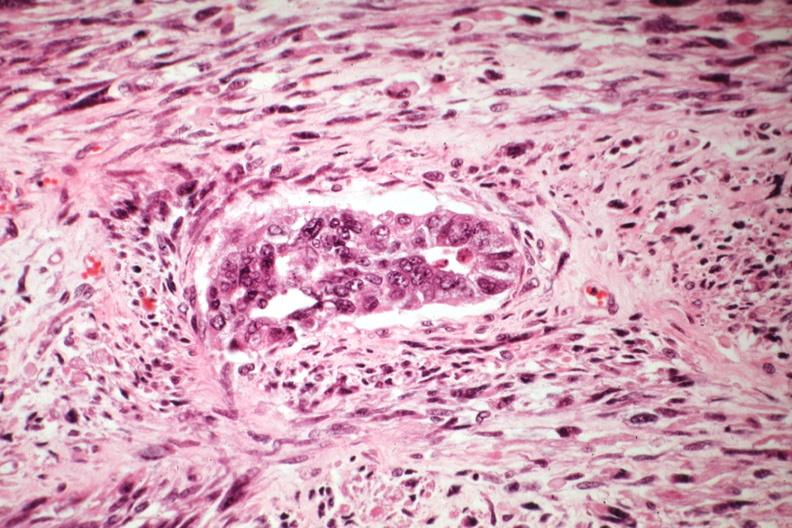s female reproductive present?
Answer the question using a single word or phrase. Yes 